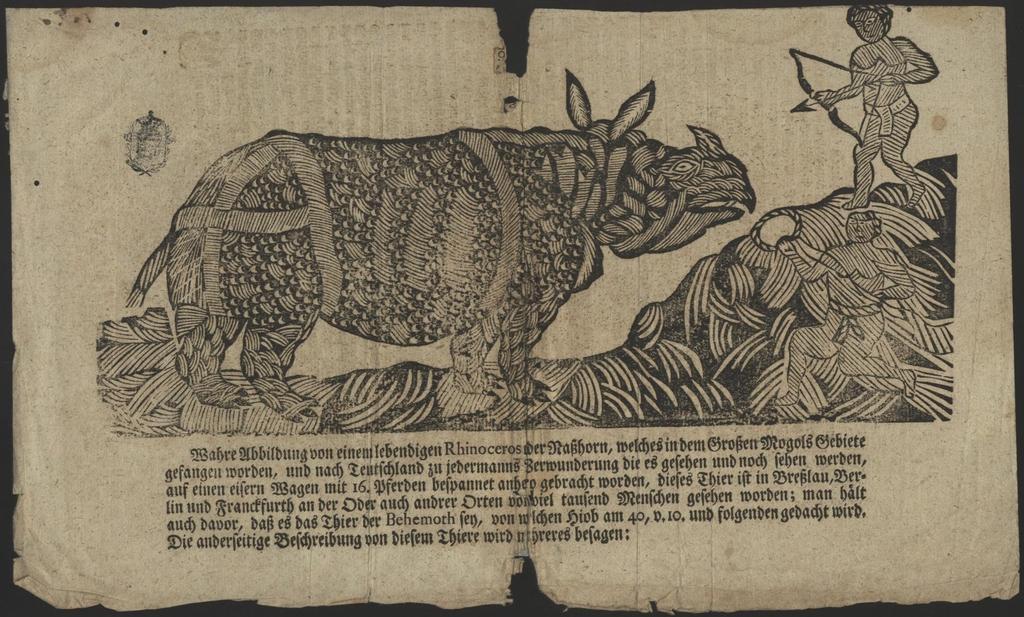Could you give a brief overview of what you see in this image? In the foreground of this picture, there is a paper on which print of a rhinoceros and two men attacking it with weapons in their hands and some text on the bottom. 